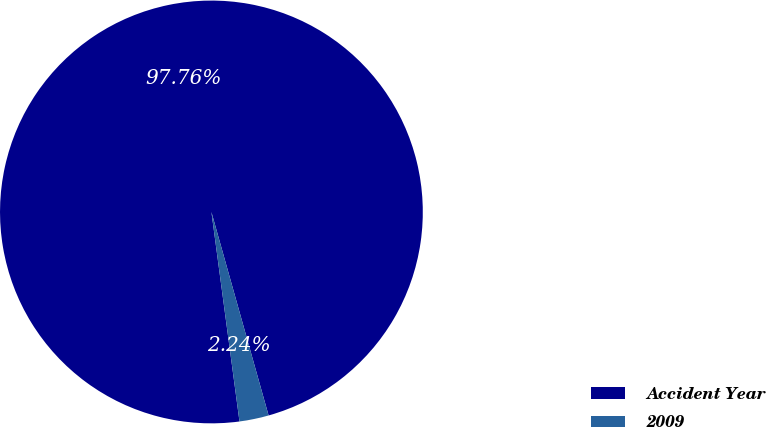<chart> <loc_0><loc_0><loc_500><loc_500><pie_chart><fcel>Accident Year<fcel>2009<nl><fcel>97.76%<fcel>2.24%<nl></chart> 